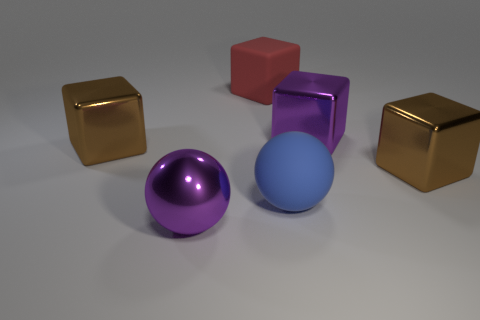Add 3 big red blocks. How many objects exist? 9 Subtract all blocks. How many objects are left? 2 Subtract 0 yellow spheres. How many objects are left? 6 Subtract all matte things. Subtract all red rubber cubes. How many objects are left? 3 Add 2 matte cubes. How many matte cubes are left? 3 Add 6 tiny cyan metallic cubes. How many tiny cyan metallic cubes exist? 6 